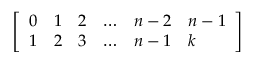<formula> <loc_0><loc_0><loc_500><loc_500>\left [ \begin{array} { l l l l l l } { 0 } & { 1 } & { 2 } & { \dots } & { n - 2 } & { n - 1 } \\ { 1 } & { 2 } & { 3 } & { \dots } & { n - 1 } & { k } \end{array} \right ]</formula> 